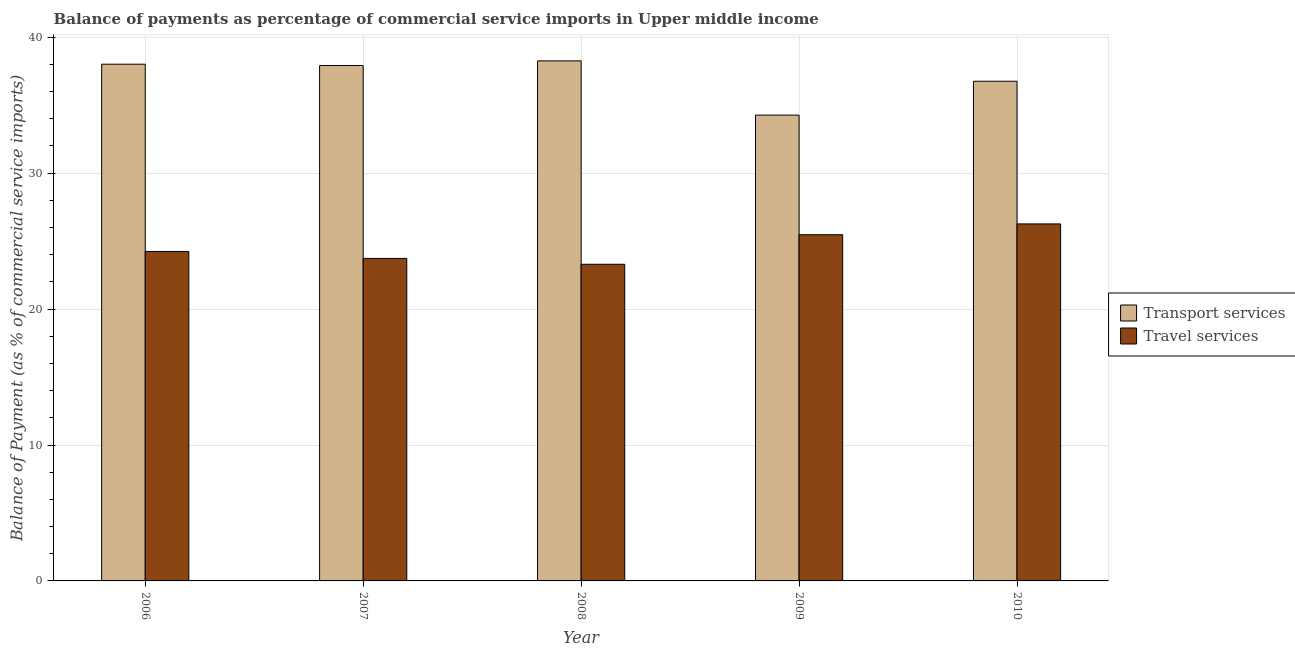Are the number of bars per tick equal to the number of legend labels?
Provide a succinct answer. Yes. Are the number of bars on each tick of the X-axis equal?
Give a very brief answer. Yes. How many bars are there on the 3rd tick from the right?
Your answer should be very brief. 2. What is the balance of payments of travel services in 2006?
Give a very brief answer. 24.24. Across all years, what is the maximum balance of payments of travel services?
Keep it short and to the point. 26.27. Across all years, what is the minimum balance of payments of travel services?
Offer a terse response. 23.3. What is the total balance of payments of travel services in the graph?
Give a very brief answer. 123. What is the difference between the balance of payments of travel services in 2006 and that in 2008?
Ensure brevity in your answer.  0.94. What is the difference between the balance of payments of transport services in 2010 and the balance of payments of travel services in 2009?
Keep it short and to the point. 2.49. What is the average balance of payments of transport services per year?
Offer a very short reply. 37.05. In the year 2010, what is the difference between the balance of payments of travel services and balance of payments of transport services?
Make the answer very short. 0. What is the ratio of the balance of payments of travel services in 2006 to that in 2007?
Make the answer very short. 1.02. What is the difference between the highest and the second highest balance of payments of travel services?
Your response must be concise. 0.79. What is the difference between the highest and the lowest balance of payments of transport services?
Provide a succinct answer. 3.99. In how many years, is the balance of payments of transport services greater than the average balance of payments of transport services taken over all years?
Give a very brief answer. 3. Is the sum of the balance of payments of travel services in 2007 and 2009 greater than the maximum balance of payments of transport services across all years?
Ensure brevity in your answer.  Yes. What does the 2nd bar from the left in 2010 represents?
Your answer should be very brief. Travel services. What does the 1st bar from the right in 2009 represents?
Ensure brevity in your answer.  Travel services. Are all the bars in the graph horizontal?
Provide a succinct answer. No. What is the difference between two consecutive major ticks on the Y-axis?
Your answer should be very brief. 10. Does the graph contain any zero values?
Your response must be concise. No. What is the title of the graph?
Offer a terse response. Balance of payments as percentage of commercial service imports in Upper middle income. Does "Passenger Transport Items" appear as one of the legend labels in the graph?
Provide a short and direct response. No. What is the label or title of the Y-axis?
Offer a very short reply. Balance of Payment (as % of commercial service imports). What is the Balance of Payment (as % of commercial service imports) in Transport services in 2006?
Give a very brief answer. 38.02. What is the Balance of Payment (as % of commercial service imports) of Travel services in 2006?
Ensure brevity in your answer.  24.24. What is the Balance of Payment (as % of commercial service imports) in Transport services in 2007?
Your answer should be very brief. 37.92. What is the Balance of Payment (as % of commercial service imports) in Travel services in 2007?
Your answer should be very brief. 23.73. What is the Balance of Payment (as % of commercial service imports) of Transport services in 2008?
Offer a terse response. 38.26. What is the Balance of Payment (as % of commercial service imports) in Travel services in 2008?
Provide a short and direct response. 23.3. What is the Balance of Payment (as % of commercial service imports) in Transport services in 2009?
Offer a terse response. 34.27. What is the Balance of Payment (as % of commercial service imports) in Travel services in 2009?
Provide a succinct answer. 25.47. What is the Balance of Payment (as % of commercial service imports) of Transport services in 2010?
Keep it short and to the point. 36.76. What is the Balance of Payment (as % of commercial service imports) in Travel services in 2010?
Give a very brief answer. 26.27. Across all years, what is the maximum Balance of Payment (as % of commercial service imports) of Transport services?
Offer a very short reply. 38.26. Across all years, what is the maximum Balance of Payment (as % of commercial service imports) in Travel services?
Keep it short and to the point. 26.27. Across all years, what is the minimum Balance of Payment (as % of commercial service imports) in Transport services?
Ensure brevity in your answer.  34.27. Across all years, what is the minimum Balance of Payment (as % of commercial service imports) of Travel services?
Ensure brevity in your answer.  23.3. What is the total Balance of Payment (as % of commercial service imports) in Transport services in the graph?
Provide a succinct answer. 185.24. What is the total Balance of Payment (as % of commercial service imports) in Travel services in the graph?
Make the answer very short. 123. What is the difference between the Balance of Payment (as % of commercial service imports) in Transport services in 2006 and that in 2007?
Give a very brief answer. 0.1. What is the difference between the Balance of Payment (as % of commercial service imports) in Travel services in 2006 and that in 2007?
Keep it short and to the point. 0.51. What is the difference between the Balance of Payment (as % of commercial service imports) in Transport services in 2006 and that in 2008?
Your answer should be compact. -0.24. What is the difference between the Balance of Payment (as % of commercial service imports) in Travel services in 2006 and that in 2008?
Ensure brevity in your answer.  0.94. What is the difference between the Balance of Payment (as % of commercial service imports) in Transport services in 2006 and that in 2009?
Provide a succinct answer. 3.75. What is the difference between the Balance of Payment (as % of commercial service imports) of Travel services in 2006 and that in 2009?
Provide a short and direct response. -1.23. What is the difference between the Balance of Payment (as % of commercial service imports) in Transport services in 2006 and that in 2010?
Your response must be concise. 1.25. What is the difference between the Balance of Payment (as % of commercial service imports) of Travel services in 2006 and that in 2010?
Ensure brevity in your answer.  -2.03. What is the difference between the Balance of Payment (as % of commercial service imports) in Transport services in 2007 and that in 2008?
Your answer should be very brief. -0.34. What is the difference between the Balance of Payment (as % of commercial service imports) of Travel services in 2007 and that in 2008?
Make the answer very short. 0.43. What is the difference between the Balance of Payment (as % of commercial service imports) in Transport services in 2007 and that in 2009?
Ensure brevity in your answer.  3.65. What is the difference between the Balance of Payment (as % of commercial service imports) in Travel services in 2007 and that in 2009?
Offer a very short reply. -1.75. What is the difference between the Balance of Payment (as % of commercial service imports) of Transport services in 2007 and that in 2010?
Provide a succinct answer. 1.16. What is the difference between the Balance of Payment (as % of commercial service imports) in Travel services in 2007 and that in 2010?
Keep it short and to the point. -2.54. What is the difference between the Balance of Payment (as % of commercial service imports) of Transport services in 2008 and that in 2009?
Offer a terse response. 3.99. What is the difference between the Balance of Payment (as % of commercial service imports) in Travel services in 2008 and that in 2009?
Keep it short and to the point. -2.18. What is the difference between the Balance of Payment (as % of commercial service imports) of Transport services in 2008 and that in 2010?
Provide a short and direct response. 1.5. What is the difference between the Balance of Payment (as % of commercial service imports) of Travel services in 2008 and that in 2010?
Keep it short and to the point. -2.97. What is the difference between the Balance of Payment (as % of commercial service imports) of Transport services in 2009 and that in 2010?
Provide a succinct answer. -2.49. What is the difference between the Balance of Payment (as % of commercial service imports) in Travel services in 2009 and that in 2010?
Offer a very short reply. -0.79. What is the difference between the Balance of Payment (as % of commercial service imports) in Transport services in 2006 and the Balance of Payment (as % of commercial service imports) in Travel services in 2007?
Ensure brevity in your answer.  14.29. What is the difference between the Balance of Payment (as % of commercial service imports) in Transport services in 2006 and the Balance of Payment (as % of commercial service imports) in Travel services in 2008?
Keep it short and to the point. 14.72. What is the difference between the Balance of Payment (as % of commercial service imports) of Transport services in 2006 and the Balance of Payment (as % of commercial service imports) of Travel services in 2009?
Keep it short and to the point. 12.55. What is the difference between the Balance of Payment (as % of commercial service imports) of Transport services in 2006 and the Balance of Payment (as % of commercial service imports) of Travel services in 2010?
Provide a succinct answer. 11.75. What is the difference between the Balance of Payment (as % of commercial service imports) of Transport services in 2007 and the Balance of Payment (as % of commercial service imports) of Travel services in 2008?
Offer a terse response. 14.62. What is the difference between the Balance of Payment (as % of commercial service imports) of Transport services in 2007 and the Balance of Payment (as % of commercial service imports) of Travel services in 2009?
Provide a succinct answer. 12.45. What is the difference between the Balance of Payment (as % of commercial service imports) in Transport services in 2007 and the Balance of Payment (as % of commercial service imports) in Travel services in 2010?
Provide a succinct answer. 11.65. What is the difference between the Balance of Payment (as % of commercial service imports) of Transport services in 2008 and the Balance of Payment (as % of commercial service imports) of Travel services in 2009?
Make the answer very short. 12.79. What is the difference between the Balance of Payment (as % of commercial service imports) in Transport services in 2008 and the Balance of Payment (as % of commercial service imports) in Travel services in 2010?
Your answer should be compact. 11.99. What is the difference between the Balance of Payment (as % of commercial service imports) of Transport services in 2009 and the Balance of Payment (as % of commercial service imports) of Travel services in 2010?
Offer a terse response. 8.01. What is the average Balance of Payment (as % of commercial service imports) of Transport services per year?
Make the answer very short. 37.05. What is the average Balance of Payment (as % of commercial service imports) in Travel services per year?
Offer a very short reply. 24.6. In the year 2006, what is the difference between the Balance of Payment (as % of commercial service imports) of Transport services and Balance of Payment (as % of commercial service imports) of Travel services?
Ensure brevity in your answer.  13.78. In the year 2007, what is the difference between the Balance of Payment (as % of commercial service imports) of Transport services and Balance of Payment (as % of commercial service imports) of Travel services?
Provide a succinct answer. 14.19. In the year 2008, what is the difference between the Balance of Payment (as % of commercial service imports) in Transport services and Balance of Payment (as % of commercial service imports) in Travel services?
Give a very brief answer. 14.96. In the year 2009, what is the difference between the Balance of Payment (as % of commercial service imports) of Transport services and Balance of Payment (as % of commercial service imports) of Travel services?
Offer a terse response. 8.8. In the year 2010, what is the difference between the Balance of Payment (as % of commercial service imports) in Transport services and Balance of Payment (as % of commercial service imports) in Travel services?
Ensure brevity in your answer.  10.5. What is the ratio of the Balance of Payment (as % of commercial service imports) of Transport services in 2006 to that in 2007?
Keep it short and to the point. 1. What is the ratio of the Balance of Payment (as % of commercial service imports) in Travel services in 2006 to that in 2007?
Offer a very short reply. 1.02. What is the ratio of the Balance of Payment (as % of commercial service imports) in Transport services in 2006 to that in 2008?
Provide a short and direct response. 0.99. What is the ratio of the Balance of Payment (as % of commercial service imports) in Travel services in 2006 to that in 2008?
Keep it short and to the point. 1.04. What is the ratio of the Balance of Payment (as % of commercial service imports) of Transport services in 2006 to that in 2009?
Your answer should be compact. 1.11. What is the ratio of the Balance of Payment (as % of commercial service imports) in Travel services in 2006 to that in 2009?
Offer a terse response. 0.95. What is the ratio of the Balance of Payment (as % of commercial service imports) in Transport services in 2006 to that in 2010?
Give a very brief answer. 1.03. What is the ratio of the Balance of Payment (as % of commercial service imports) in Travel services in 2006 to that in 2010?
Offer a terse response. 0.92. What is the ratio of the Balance of Payment (as % of commercial service imports) of Travel services in 2007 to that in 2008?
Offer a terse response. 1.02. What is the ratio of the Balance of Payment (as % of commercial service imports) of Transport services in 2007 to that in 2009?
Provide a succinct answer. 1.11. What is the ratio of the Balance of Payment (as % of commercial service imports) of Travel services in 2007 to that in 2009?
Your response must be concise. 0.93. What is the ratio of the Balance of Payment (as % of commercial service imports) in Transport services in 2007 to that in 2010?
Your answer should be compact. 1.03. What is the ratio of the Balance of Payment (as % of commercial service imports) of Travel services in 2007 to that in 2010?
Ensure brevity in your answer.  0.9. What is the ratio of the Balance of Payment (as % of commercial service imports) of Transport services in 2008 to that in 2009?
Provide a short and direct response. 1.12. What is the ratio of the Balance of Payment (as % of commercial service imports) in Travel services in 2008 to that in 2009?
Give a very brief answer. 0.91. What is the ratio of the Balance of Payment (as % of commercial service imports) of Transport services in 2008 to that in 2010?
Your answer should be very brief. 1.04. What is the ratio of the Balance of Payment (as % of commercial service imports) in Travel services in 2008 to that in 2010?
Ensure brevity in your answer.  0.89. What is the ratio of the Balance of Payment (as % of commercial service imports) of Transport services in 2009 to that in 2010?
Your response must be concise. 0.93. What is the ratio of the Balance of Payment (as % of commercial service imports) in Travel services in 2009 to that in 2010?
Offer a terse response. 0.97. What is the difference between the highest and the second highest Balance of Payment (as % of commercial service imports) of Transport services?
Offer a very short reply. 0.24. What is the difference between the highest and the second highest Balance of Payment (as % of commercial service imports) of Travel services?
Provide a succinct answer. 0.79. What is the difference between the highest and the lowest Balance of Payment (as % of commercial service imports) in Transport services?
Your answer should be compact. 3.99. What is the difference between the highest and the lowest Balance of Payment (as % of commercial service imports) of Travel services?
Keep it short and to the point. 2.97. 